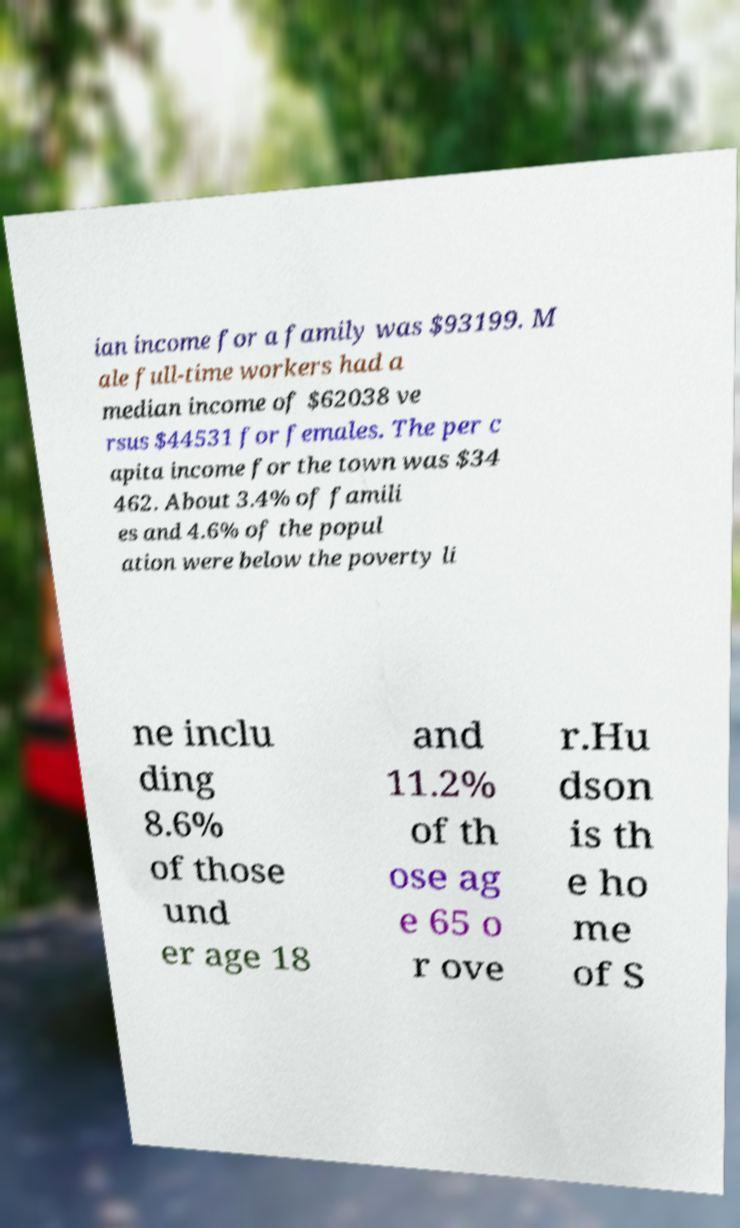Could you extract and type out the text from this image? ian income for a family was $93199. M ale full-time workers had a median income of $62038 ve rsus $44531 for females. The per c apita income for the town was $34 462. About 3.4% of famili es and 4.6% of the popul ation were below the poverty li ne inclu ding 8.6% of those und er age 18 and 11.2% of th ose ag e 65 o r ove r.Hu dson is th e ho me of S 